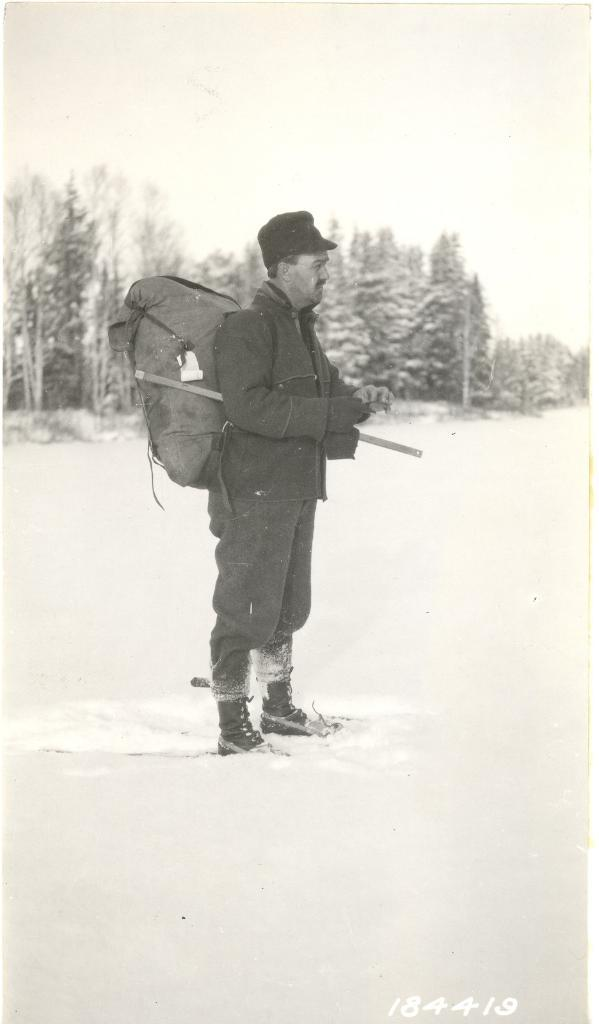What is the color scheme of the image? The image is black and white. What is the person in the image holding? The person is holding a bag in the image. What type of natural scenery can be seen in the image? There are trees in the image. What is present at the bottom of the image? There is a watermark at the bottom of the image. What is visible in the background of the image? The sky is visible in the background of the image. What type of joke is being told by the trees in the image? There are no jokes being told by the trees in the image, as trees do not have the ability to tell jokes. What type of books can be seen on the person's bag in the image? There are no books visible on the person's bag in the image. 